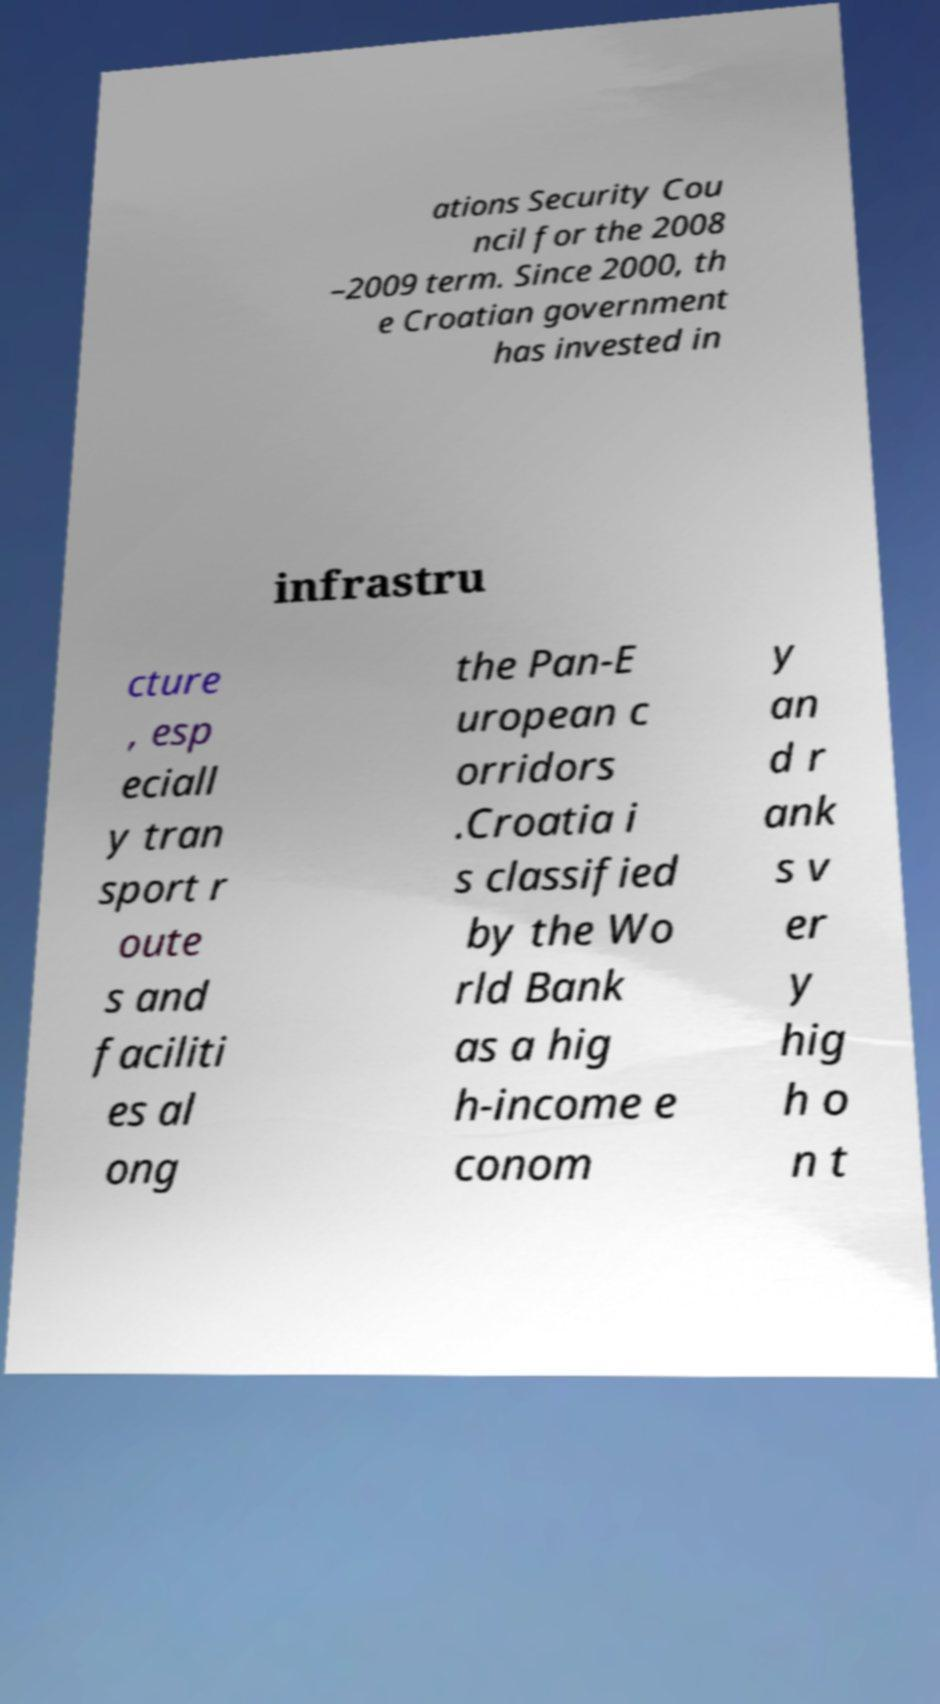Can you accurately transcribe the text from the provided image for me? ations Security Cou ncil for the 2008 –2009 term. Since 2000, th e Croatian government has invested in infrastru cture , esp eciall y tran sport r oute s and faciliti es al ong the Pan-E uropean c orridors .Croatia i s classified by the Wo rld Bank as a hig h-income e conom y an d r ank s v er y hig h o n t 